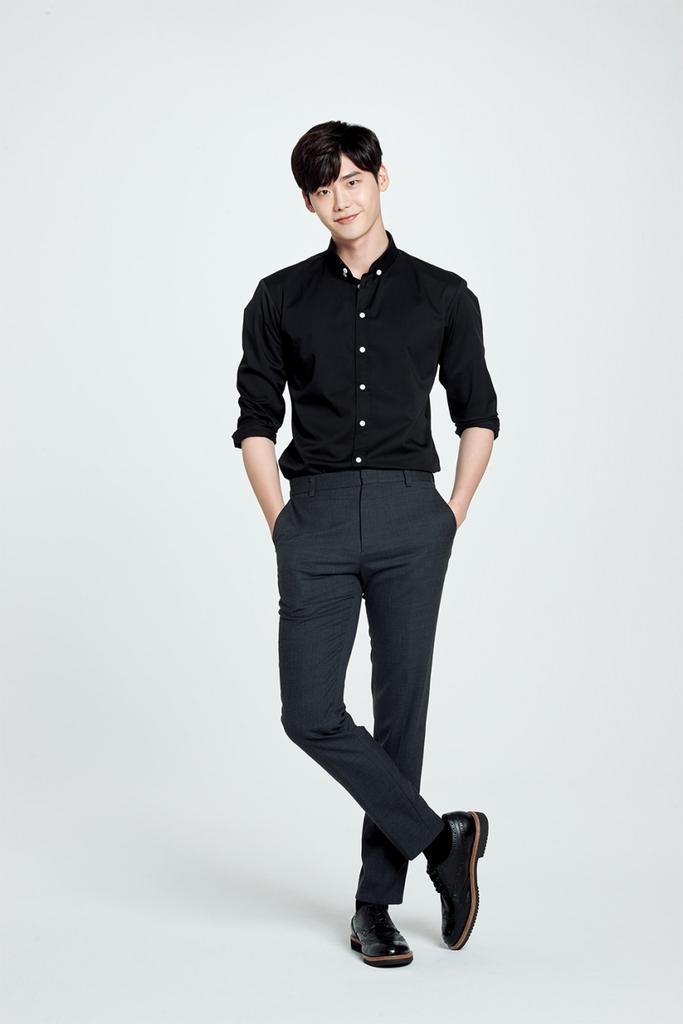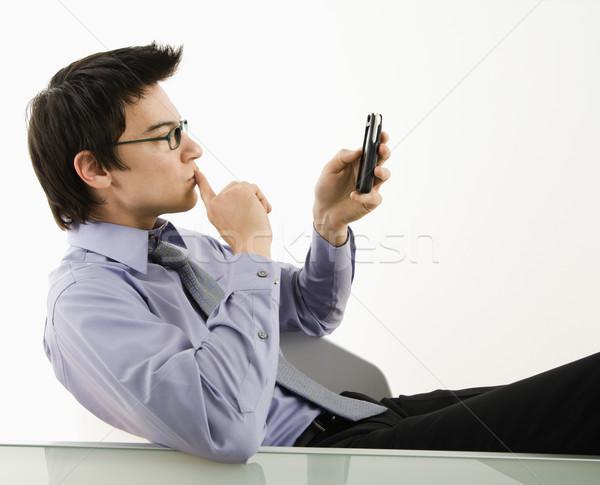The first image is the image on the left, the second image is the image on the right. Given the left and right images, does the statement "The left and right image contains the same number of men." hold true? Answer yes or no. Yes. 